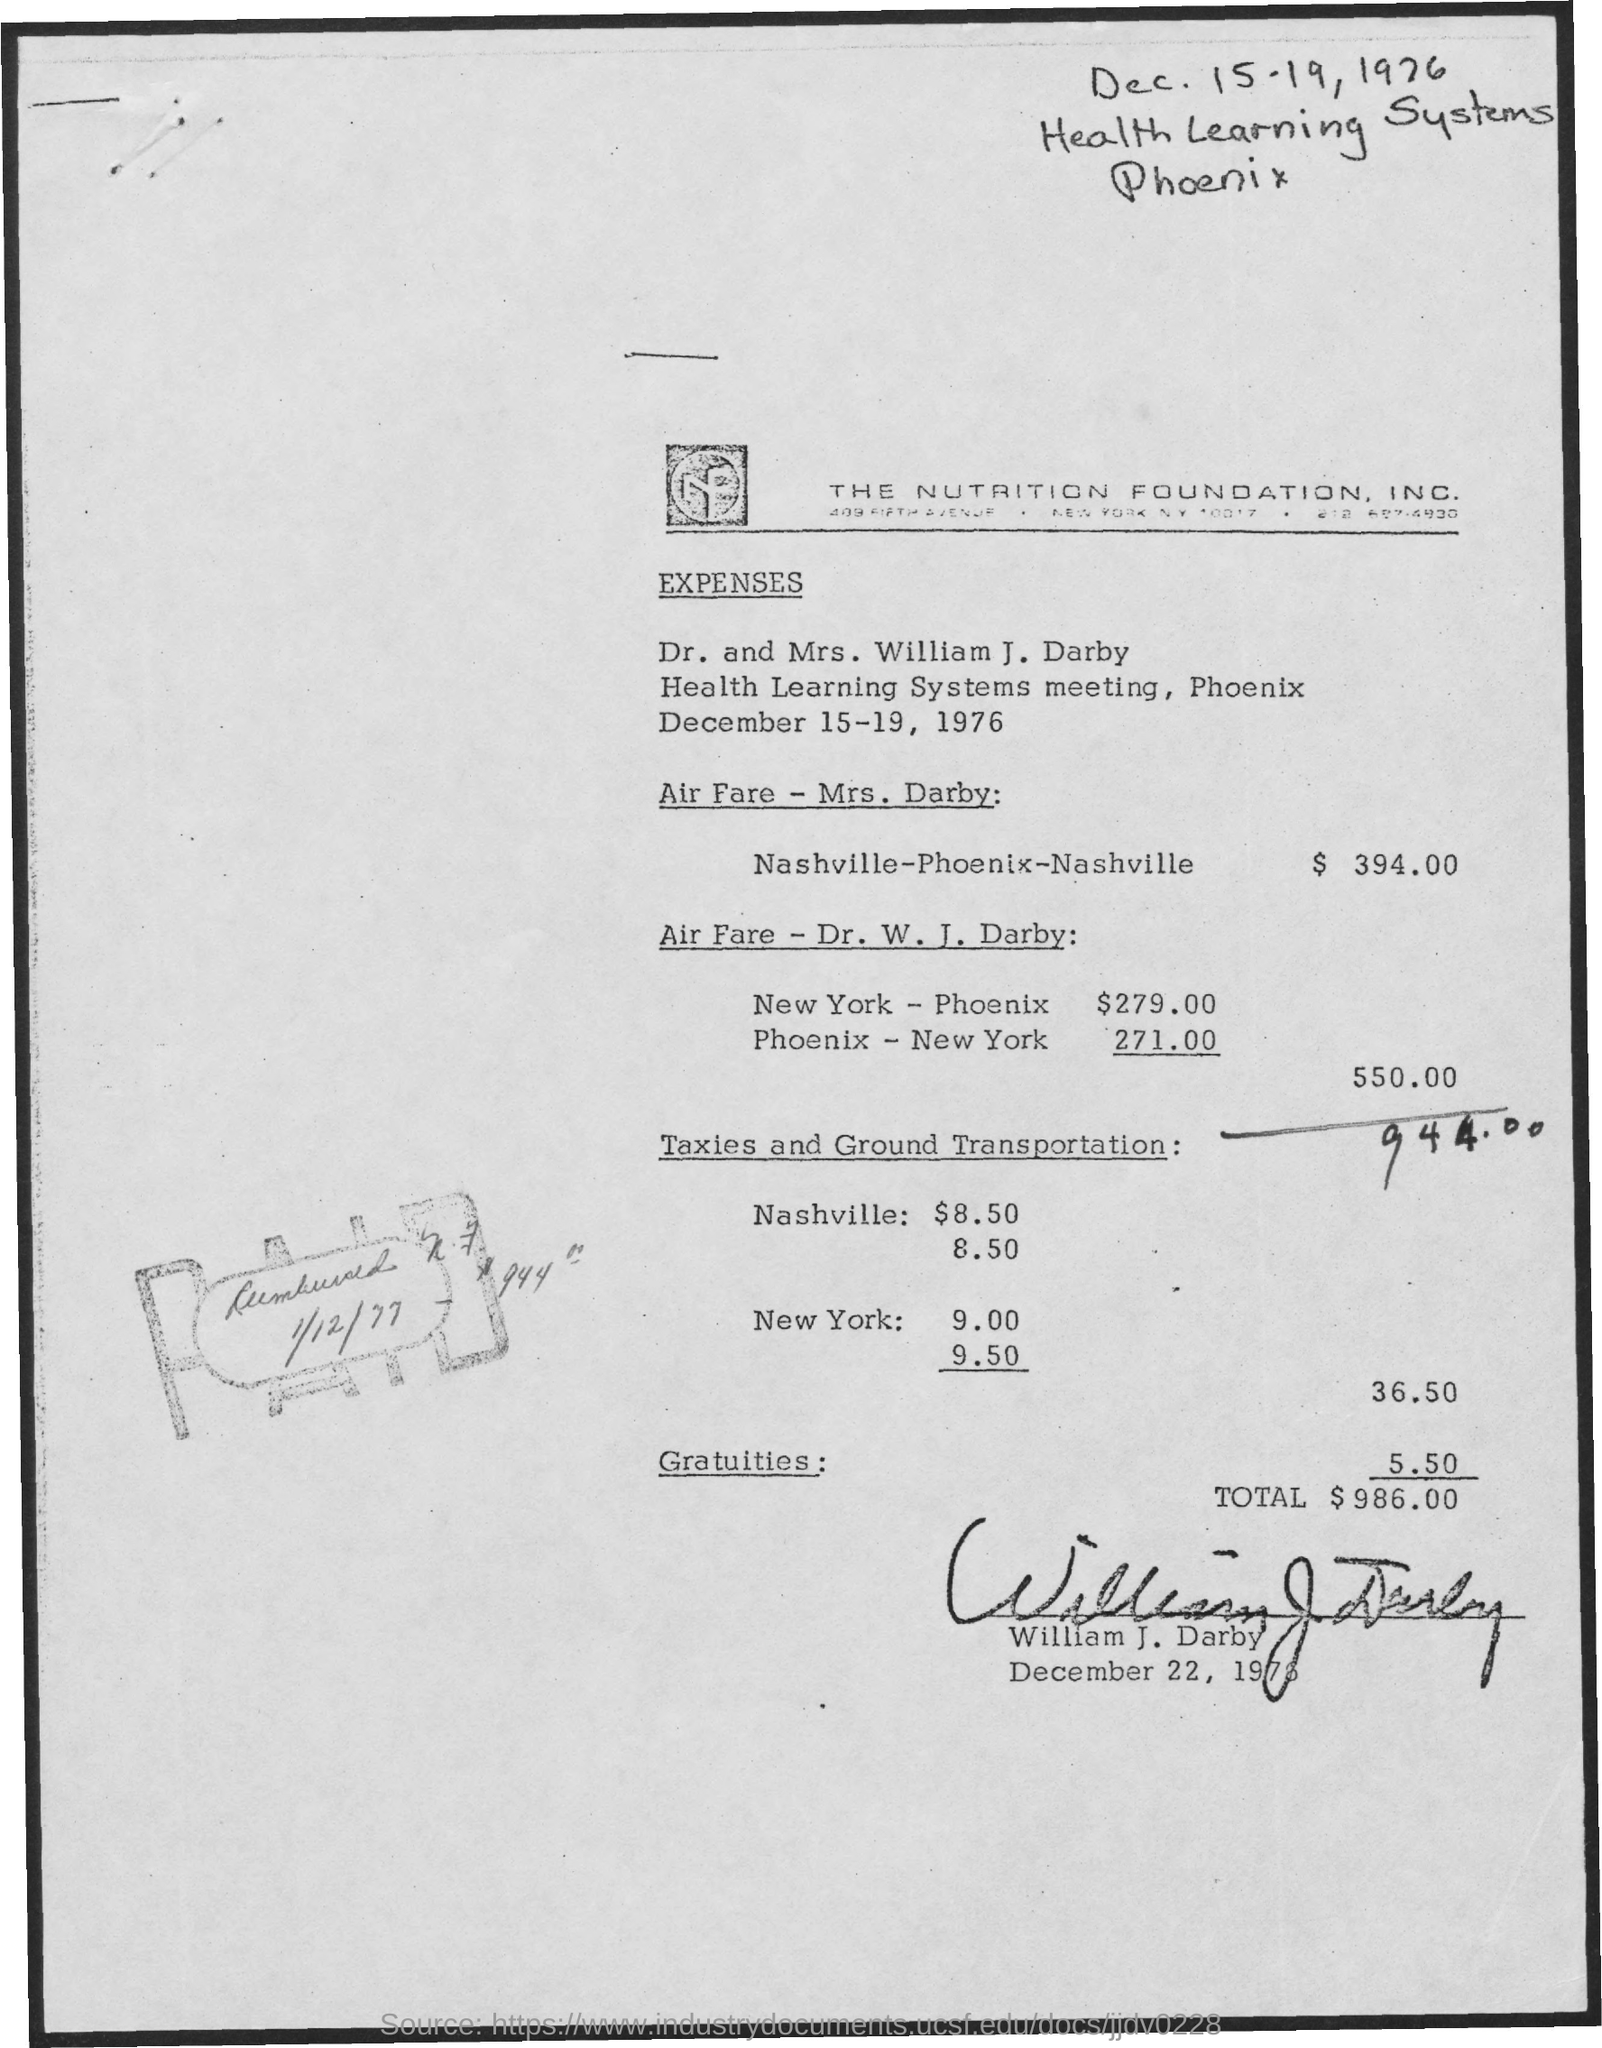What is the full-form of  nf?
Provide a short and direct response. Nutrition Foundation. What is the total amount of expenses ?
Keep it short and to the point. 986. What is the amount of gratuities ?
Ensure brevity in your answer.  $ 5.50. What is the total amount of taxies and ground transportation ?
Offer a very short reply. 36.50. What is the amount of airfare for mrs. darby?
Offer a terse response. $ 394. What is the total amount for airfare for dr. w. j. darby?
Provide a short and direct response. 550.00. 